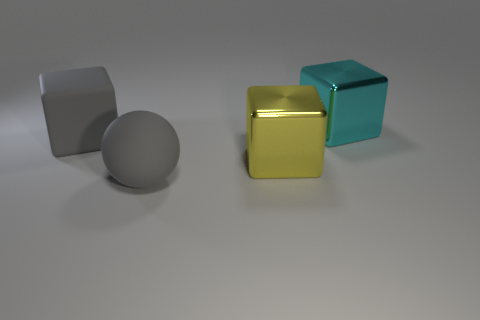There is a big matte thing that is on the right side of the rubber object on the left side of the gray matte thing that is in front of the big gray matte block; what color is it?
Your answer should be compact. Gray. There is a gray object behind the yellow cube; is it the same shape as the cyan metallic object?
Offer a terse response. Yes. What color is the other shiny thing that is the same size as the cyan thing?
Provide a succinct answer. Yellow. What number of large balls are there?
Provide a short and direct response. 1. Are the gray object behind the yellow metallic thing and the large cyan block made of the same material?
Offer a very short reply. No. What material is the thing that is both left of the yellow shiny object and behind the large gray sphere?
Your response must be concise. Rubber. The object that is the same color as the large rubber sphere is what size?
Give a very brief answer. Large. The big gray object in front of the large cube that is on the left side of the gray ball is made of what material?
Provide a succinct answer. Rubber. What size is the gray object that is to the left of the big rubber thing right of the rubber object on the left side of the large matte sphere?
Keep it short and to the point. Large. What number of large gray things have the same material as the sphere?
Your answer should be very brief. 1. 